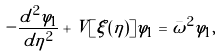Convert formula to latex. <formula><loc_0><loc_0><loc_500><loc_500>- \frac { d ^ { 2 } \varphi _ { 1 } } { d \eta ^ { 2 } } + V [ \xi ( \eta ) ] \varphi _ { 1 } = \bar { \omega } ^ { 2 } \varphi _ { 1 } ,</formula> 